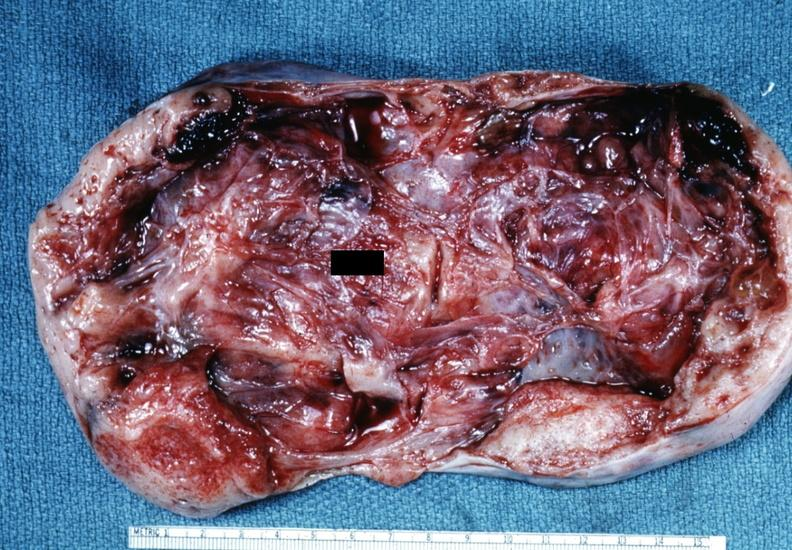s granulosa cell tumor present?
Answer the question using a single word or phrase. Yes 